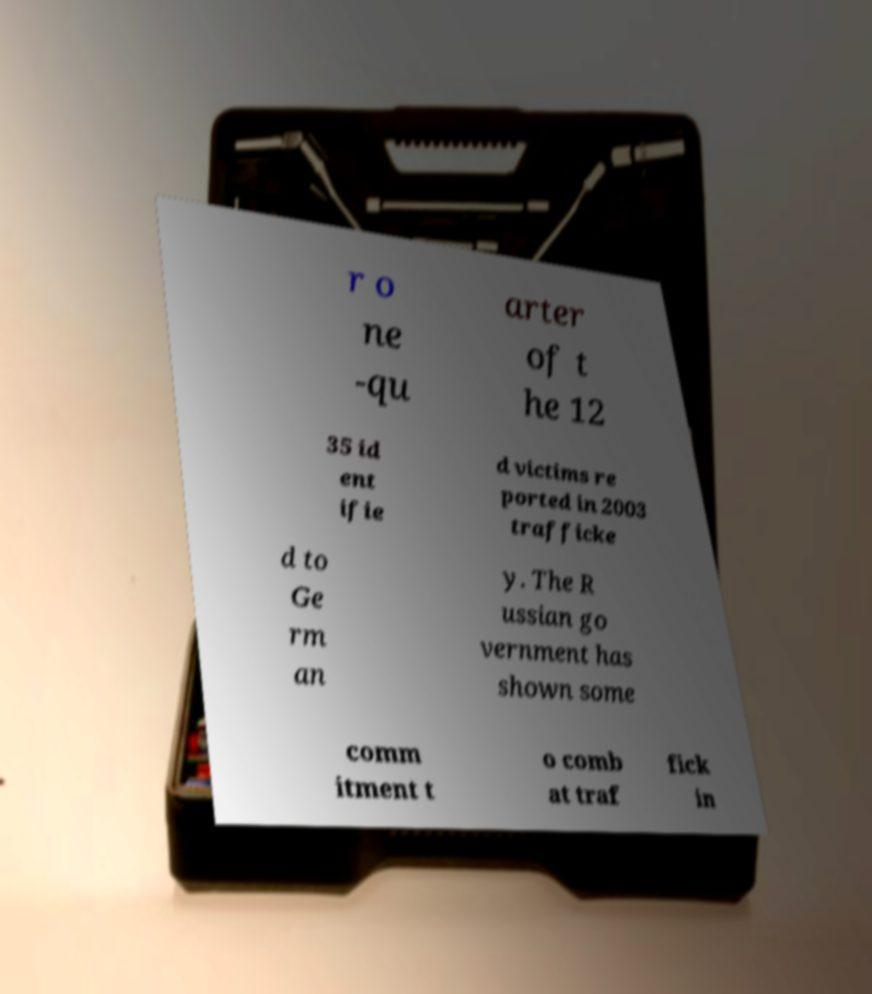Can you read and provide the text displayed in the image?This photo seems to have some interesting text. Can you extract and type it out for me? r o ne -qu arter of t he 12 35 id ent ifie d victims re ported in 2003 trafficke d to Ge rm an y. The R ussian go vernment has shown some comm itment t o comb at traf fick in 